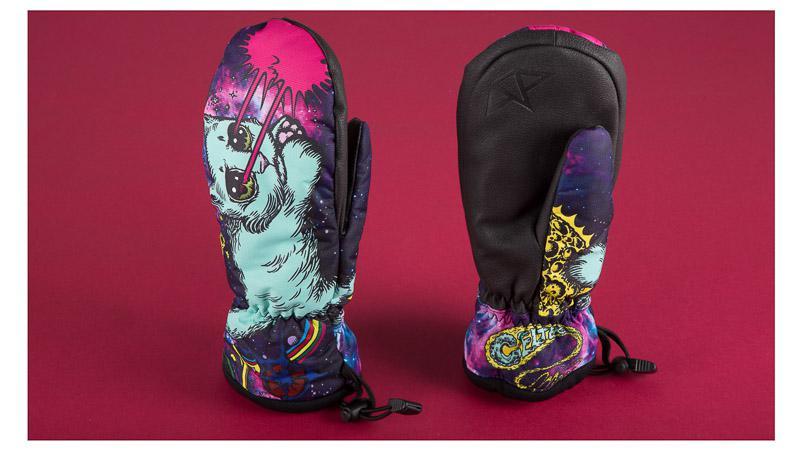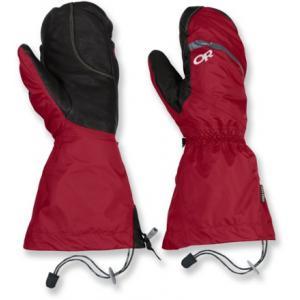The first image is the image on the left, the second image is the image on the right. Examine the images to the left and right. Is the description "The pair of gloves on the right is at least mostly red in color." accurate? Answer yes or no. Yes. 